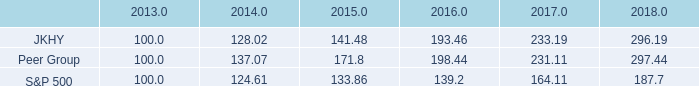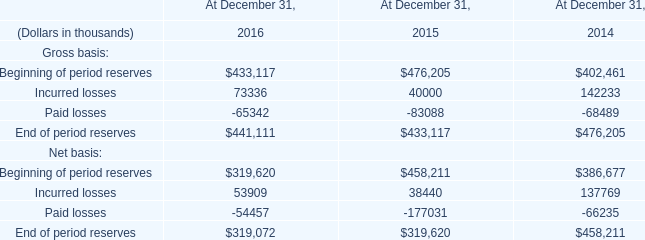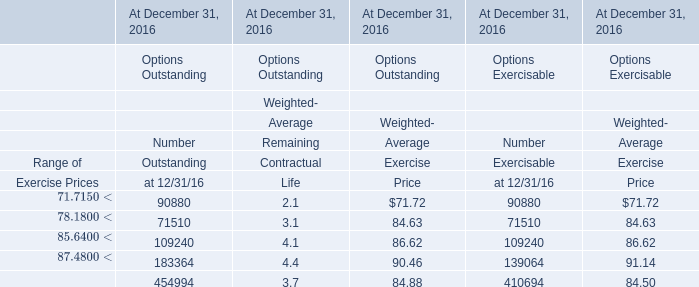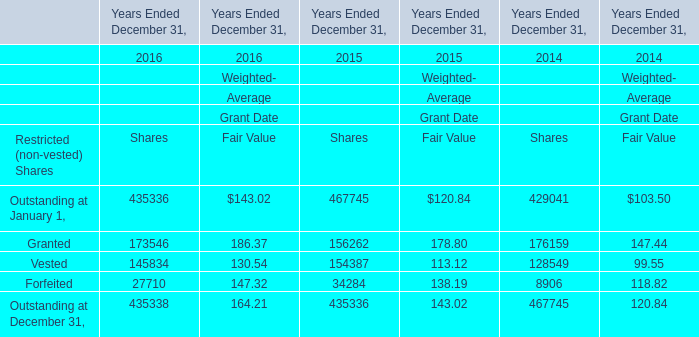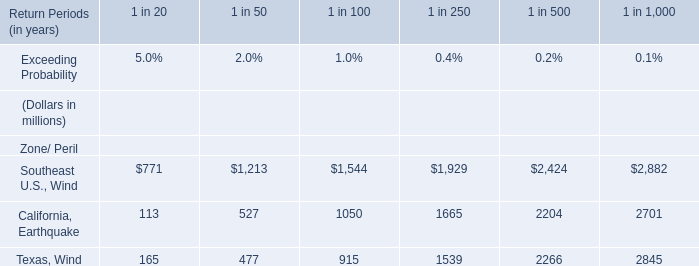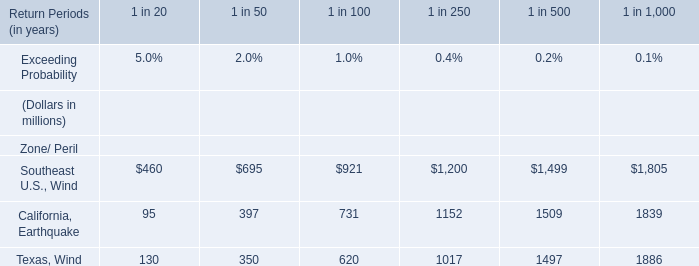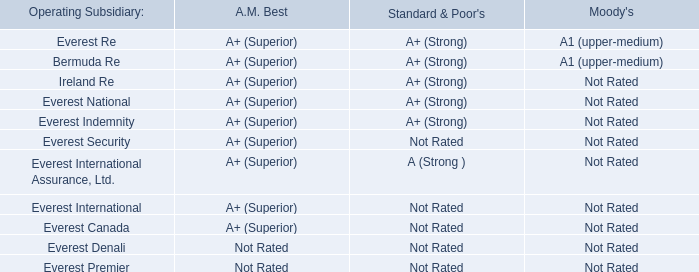What is the proportion of all Sharesthat are greater than 100000 to the total amount of Shares, in 2016 
Computations: ((((173546 + 145834) + 435336) + 435338) / ((((173546 + 145834) + 435336) + 435338) + 27710))
Answer: 0.97725. 